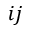Convert formula to latex. <formula><loc_0><loc_0><loc_500><loc_500>i j</formula> 